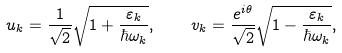<formula> <loc_0><loc_0><loc_500><loc_500>u _ { k } = \frac { 1 } { \sqrt { 2 } } \sqrt { 1 + \frac { \varepsilon _ { k } } { \hbar { \omega } _ { k } } } , \quad v _ { k } = \frac { e ^ { i \theta } } { \sqrt { 2 } } \sqrt { 1 - \frac { \varepsilon _ { k } } { \hbar { \omega } _ { k } } } ,</formula> 